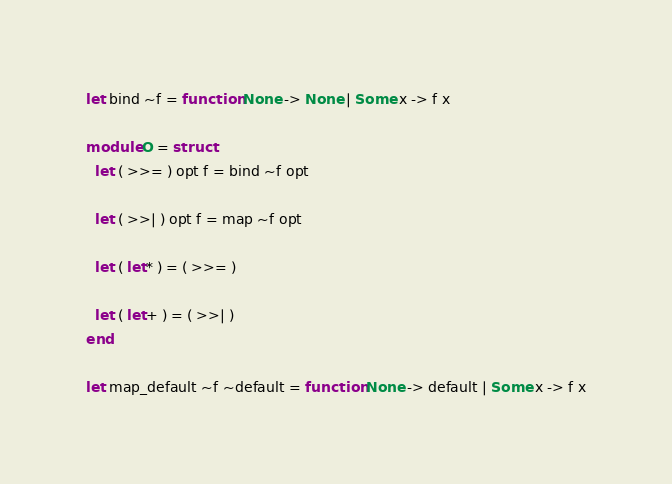<code> <loc_0><loc_0><loc_500><loc_500><_OCaml_>
let bind ~f = function None -> None | Some x -> f x

module O = struct
  let ( >>= ) opt f = bind ~f opt

  let ( >>| ) opt f = map ~f opt

  let ( let* ) = ( >>= )

  let ( let+ ) = ( >>| )
end

let map_default ~f ~default = function None -> default | Some x -> f x
</code> 